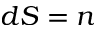<formula> <loc_0><loc_0><loc_500><loc_500>d S = n</formula> 